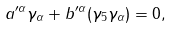<formula> <loc_0><loc_0><loc_500><loc_500>a ^ { \prime \alpha } \gamma _ { \alpha } + b ^ { \prime \alpha } ( \gamma _ { 5 } \gamma _ { \alpha } ) = 0 ,</formula> 